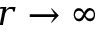Convert formula to latex. <formula><loc_0><loc_0><loc_500><loc_500>r \rightarrow \infty</formula> 